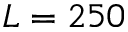Convert formula to latex. <formula><loc_0><loc_0><loc_500><loc_500>L = 2 5 0</formula> 